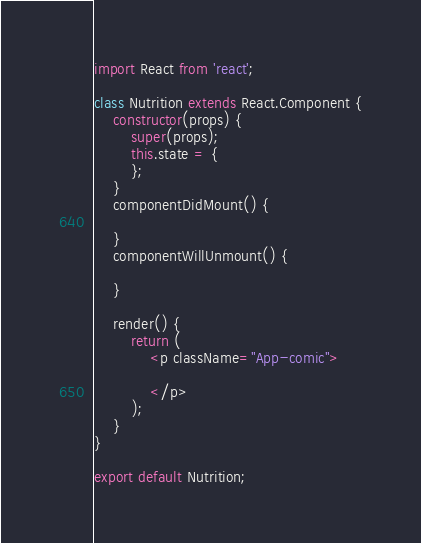<code> <loc_0><loc_0><loc_500><loc_500><_JavaScript_>import React from 'react';

class Nutrition extends React.Component {
    constructor(props) {
        super(props);
        this.state = {
        };
    }
    componentDidMount() {

    }
    componentWillUnmount() {

    }

    render() {
        return (
            <p className="App-comic">

            </p>
        );
    }
}

export default Nutrition;</code> 